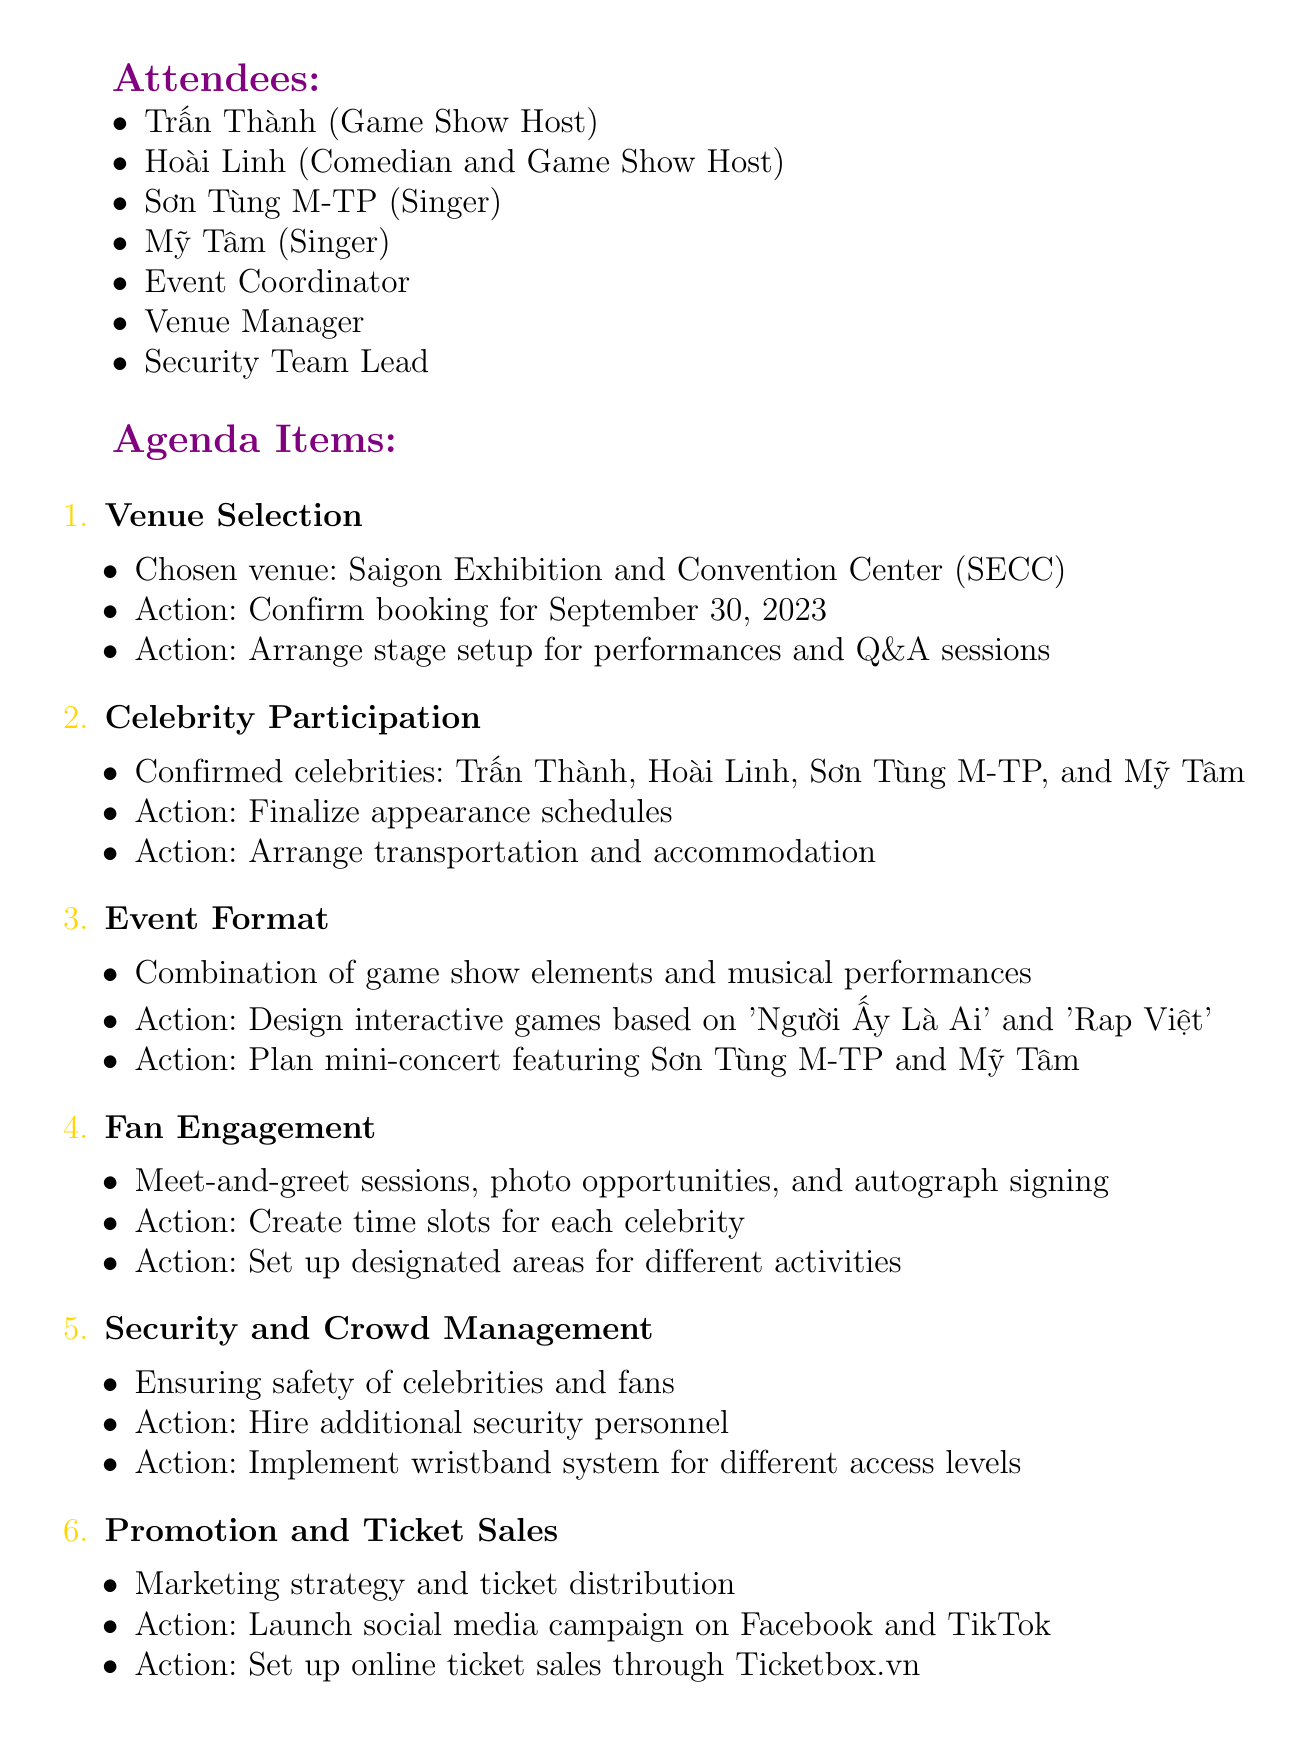What is the date of the meeting? The date of the meeting is stated directly at the top of the document.
Answer: 2023-08-15 What venue was chosen for the event? The venue selection details are provided in the agenda items section.
Answer: Saigon Exhibition and Convention Center (SECC) Who are the confirmed celebrities for the event? The document lists confirmed celebrities under the Celebrity Participation agenda.
Answer: Trấn Thành, Hoài Linh, Sơn Tùng M-TP, and Mỹ Tâm What is one of the activities planned for fan engagement? The agenda item on fan engagement provides specific details about activities planned for the fans.
Answer: Meet-and-greet sessions How many days until the next meeting? The date of the next meeting is provided, and the difference from the current meeting date can be calculated.
Answer: 14 days What security measure is mentioned in the document? The agenda item on Security and Crowd Management outlines specific action items for safety during the event.
Answer: Hire additional security personnel When is the event scheduled to take place? The specific date for the event is mentioned in the Venue Selection action items.
Answer: September 30, 2023 What platform will be used for online ticket sales? The Promotion and Ticket Sales agenda item specifies the platform for ticket sales.
Answer: Ticketbox.vn What type of event format is being planned? The Event Format agenda item describes the nature of the event.
Answer: Combination of game show elements and musical performances 